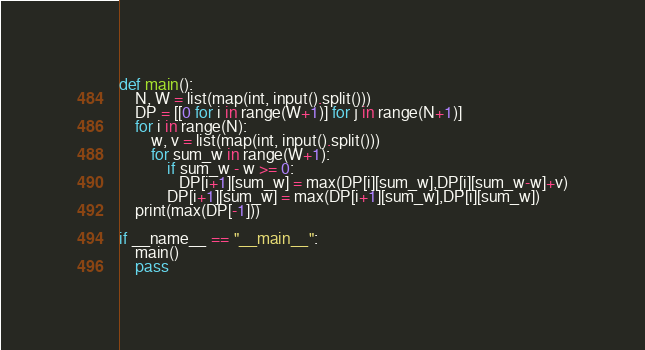Convert code to text. <code><loc_0><loc_0><loc_500><loc_500><_Python_>def main():
    N, W = list(map(int, input().split()))
    DP = [[0 for i in range(W+1)] for j in range(N+1)]
    for i in range(N):
        w, v = list(map(int, input().split()))
        for sum_w in range(W+1):
            if sum_w - w >= 0:
               DP[i+1][sum_w] = max(DP[i][sum_w],DP[i][sum_w-w]+v)
            DP[i+1][sum_w] = max(DP[i+1][sum_w],DP[i][sum_w])
    print(max(DP[-1]))

if __name__ == "__main__":
    main()
    pass</code> 